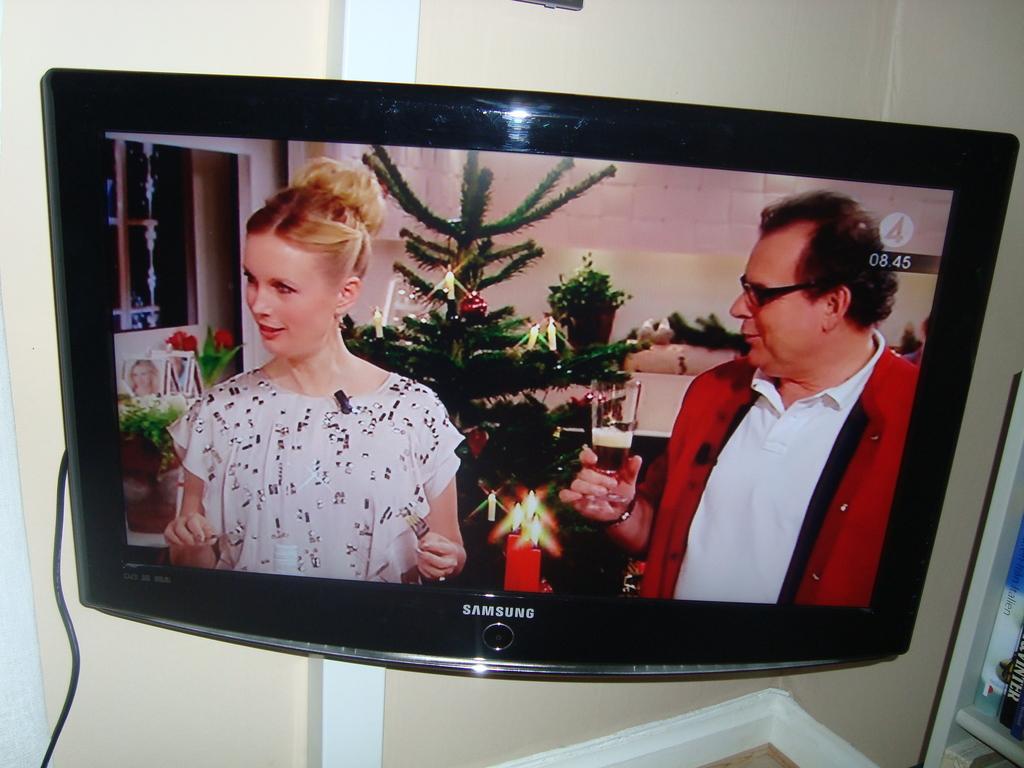Please provide a concise description of this image. In the image we can see a television and the screen of the television, in it we can see a man and a woman wearing clothes. This is a cable wire and the wall. 